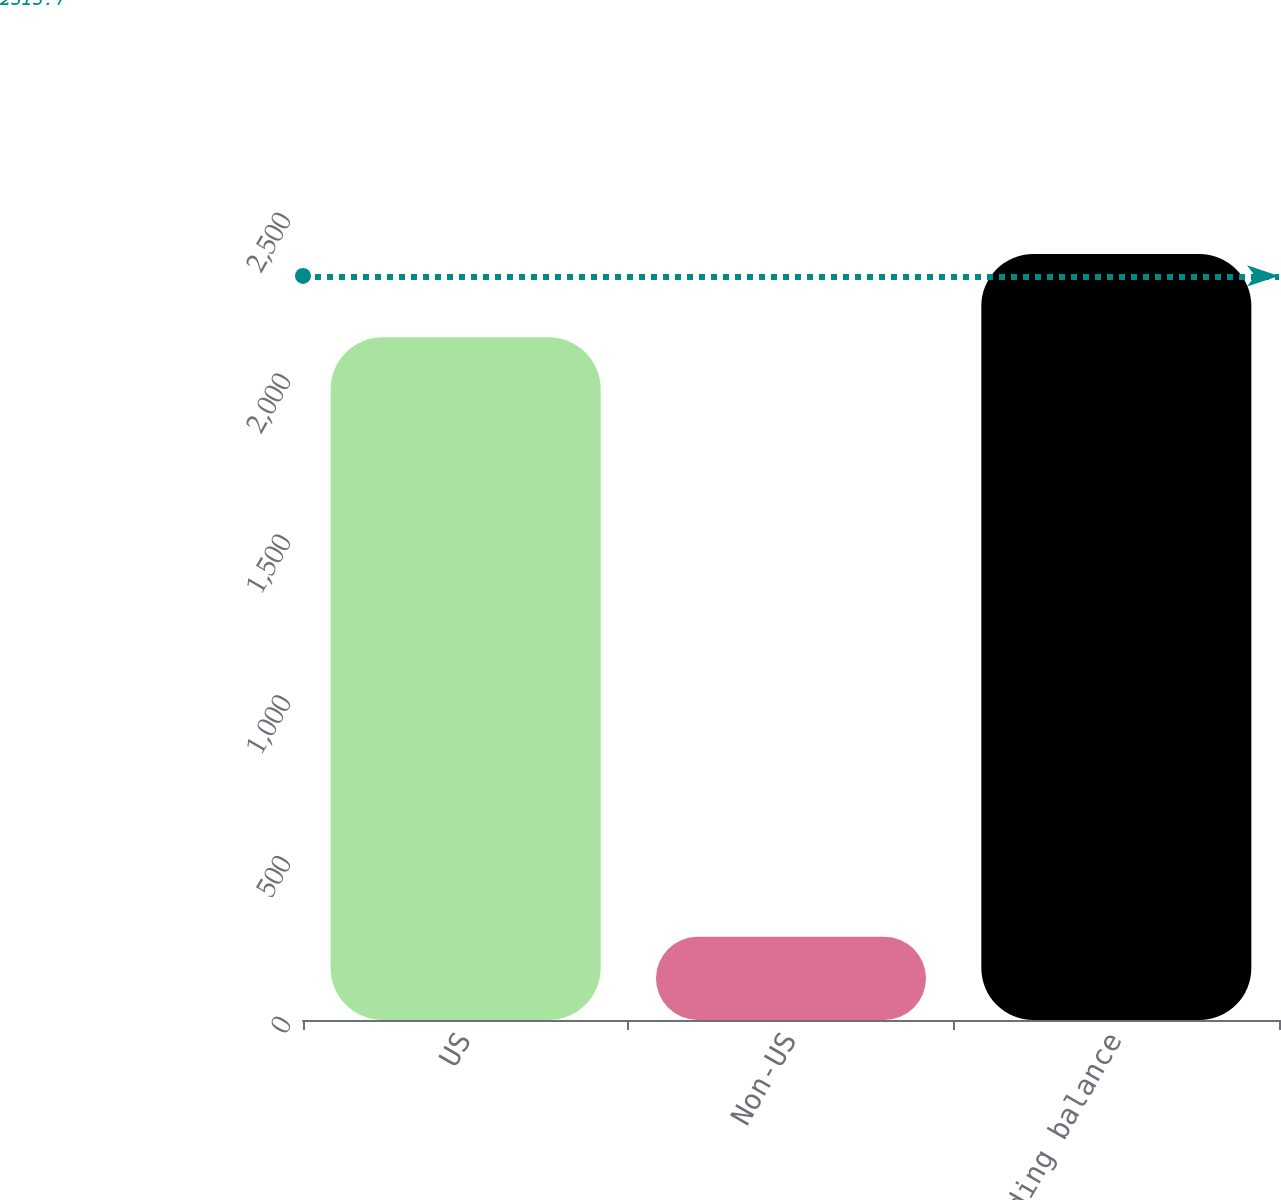Convert chart. <chart><loc_0><loc_0><loc_500><loc_500><bar_chart><fcel>US<fcel>Non-US<fcel>Ending balance<nl><fcel>2123<fcel>259<fcel>2382<nl></chart> 